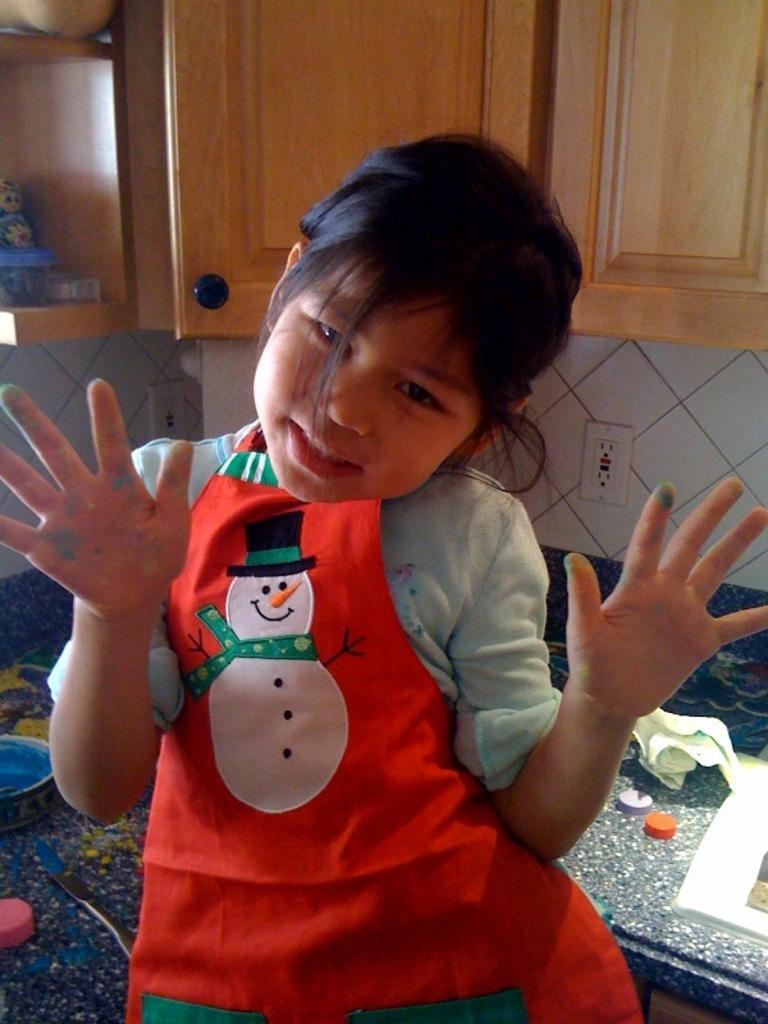Can you describe this image briefly? In this image we can see a girl wearing a dress is standing on the ground. In the background, we can see some caps, group of bowls and pipes placed on the countertop, group of cupboards and some containers placed on racks and switch boards on the wall. 